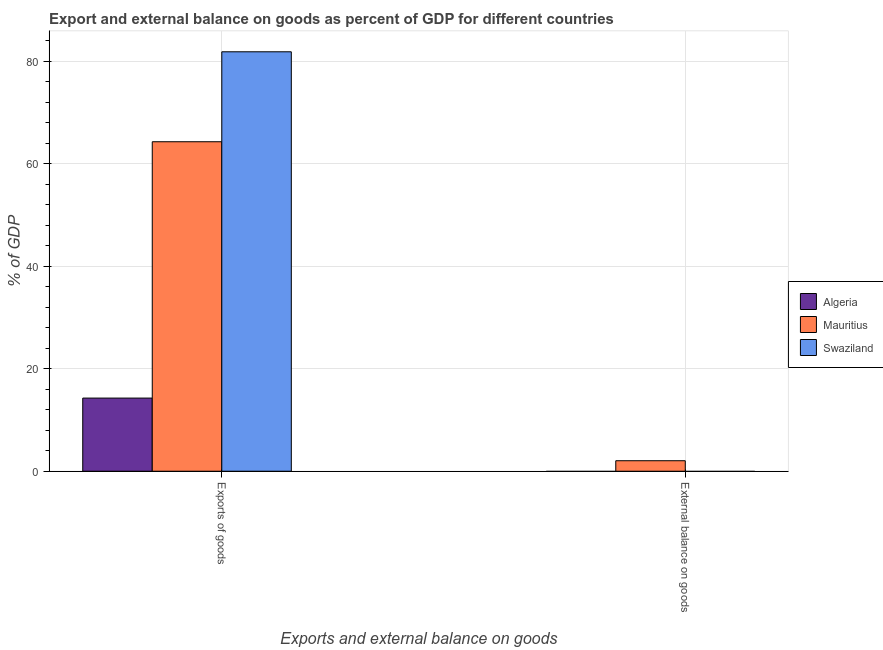Are the number of bars on each tick of the X-axis equal?
Make the answer very short. No. How many bars are there on the 1st tick from the right?
Offer a very short reply. 1. What is the label of the 1st group of bars from the left?
Offer a very short reply. Exports of goods. What is the export of goods as percentage of gdp in Algeria?
Provide a succinct answer. 14.27. Across all countries, what is the maximum external balance on goods as percentage of gdp?
Give a very brief answer. 2.05. In which country was the external balance on goods as percentage of gdp maximum?
Your response must be concise. Mauritius. What is the total external balance on goods as percentage of gdp in the graph?
Offer a terse response. 2.05. What is the difference between the export of goods as percentage of gdp in Algeria and that in Mauritius?
Your response must be concise. -50.02. What is the difference between the export of goods as percentage of gdp in Swaziland and the external balance on goods as percentage of gdp in Mauritius?
Provide a short and direct response. 79.8. What is the average external balance on goods as percentage of gdp per country?
Your answer should be compact. 0.68. What is the difference between the export of goods as percentage of gdp and external balance on goods as percentage of gdp in Mauritius?
Provide a short and direct response. 62.25. In how many countries, is the external balance on goods as percentage of gdp greater than 56 %?
Your response must be concise. 0. What is the ratio of the export of goods as percentage of gdp in Swaziland to that in Mauritius?
Offer a terse response. 1.27. How many countries are there in the graph?
Offer a terse response. 3. Are the values on the major ticks of Y-axis written in scientific E-notation?
Your answer should be compact. No. Where does the legend appear in the graph?
Offer a very short reply. Center right. How many legend labels are there?
Your answer should be very brief. 3. What is the title of the graph?
Your answer should be compact. Export and external balance on goods as percent of GDP for different countries. What is the label or title of the X-axis?
Provide a short and direct response. Exports and external balance on goods. What is the label or title of the Y-axis?
Offer a terse response. % of GDP. What is the % of GDP in Algeria in Exports of goods?
Offer a very short reply. 14.27. What is the % of GDP of Mauritius in Exports of goods?
Offer a terse response. 64.3. What is the % of GDP of Swaziland in Exports of goods?
Make the answer very short. 81.85. What is the % of GDP of Algeria in External balance on goods?
Your answer should be compact. 0. What is the % of GDP in Mauritius in External balance on goods?
Ensure brevity in your answer.  2.05. What is the % of GDP of Swaziland in External balance on goods?
Your answer should be compact. 0. Across all Exports and external balance on goods, what is the maximum % of GDP in Algeria?
Provide a short and direct response. 14.27. Across all Exports and external balance on goods, what is the maximum % of GDP in Mauritius?
Offer a very short reply. 64.3. Across all Exports and external balance on goods, what is the maximum % of GDP of Swaziland?
Make the answer very short. 81.85. Across all Exports and external balance on goods, what is the minimum % of GDP of Algeria?
Offer a very short reply. 0. Across all Exports and external balance on goods, what is the minimum % of GDP of Mauritius?
Offer a terse response. 2.05. Across all Exports and external balance on goods, what is the minimum % of GDP of Swaziland?
Your answer should be very brief. 0. What is the total % of GDP of Algeria in the graph?
Offer a terse response. 14.27. What is the total % of GDP in Mauritius in the graph?
Give a very brief answer. 66.34. What is the total % of GDP in Swaziland in the graph?
Offer a terse response. 81.85. What is the difference between the % of GDP of Mauritius in Exports of goods and that in External balance on goods?
Your answer should be very brief. 62.25. What is the difference between the % of GDP of Algeria in Exports of goods and the % of GDP of Mauritius in External balance on goods?
Offer a very short reply. 12.23. What is the average % of GDP of Algeria per Exports and external balance on goods?
Give a very brief answer. 7.14. What is the average % of GDP in Mauritius per Exports and external balance on goods?
Your response must be concise. 33.17. What is the average % of GDP of Swaziland per Exports and external balance on goods?
Offer a terse response. 40.92. What is the difference between the % of GDP of Algeria and % of GDP of Mauritius in Exports of goods?
Your answer should be compact. -50.02. What is the difference between the % of GDP in Algeria and % of GDP in Swaziland in Exports of goods?
Your response must be concise. -67.57. What is the difference between the % of GDP in Mauritius and % of GDP in Swaziland in Exports of goods?
Make the answer very short. -17.55. What is the ratio of the % of GDP of Mauritius in Exports of goods to that in External balance on goods?
Keep it short and to the point. 31.4. What is the difference between the highest and the second highest % of GDP of Mauritius?
Ensure brevity in your answer.  62.25. What is the difference between the highest and the lowest % of GDP of Algeria?
Offer a very short reply. 14.27. What is the difference between the highest and the lowest % of GDP of Mauritius?
Ensure brevity in your answer.  62.25. What is the difference between the highest and the lowest % of GDP in Swaziland?
Your answer should be very brief. 81.85. 